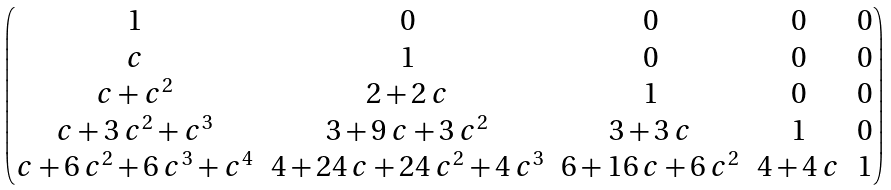Convert formula to latex. <formula><loc_0><loc_0><loc_500><loc_500>\begin{pmatrix} 1 & 0 & 0 & 0 & 0 \\ c & 1 & 0 & 0 & 0 \\ c + c ^ { 2 } & 2 + 2 \, c & 1 & 0 & 0 \\ c + 3 \, c ^ { 2 } + c ^ { 3 } & 3 + 9 \, c + 3 \, c ^ { 2 } & 3 + 3 \, c & 1 & 0 \\ c + 6 \, c ^ { 2 } + 6 \, c ^ { 3 } + c ^ { 4 } & 4 + 2 4 \, c + 2 4 \, c ^ { 2 } + 4 \, c ^ { 3 } & 6 + 1 6 \, c + 6 \, c ^ { 2 } & 4 + 4 \, c & 1 \\ \end{pmatrix}</formula> 